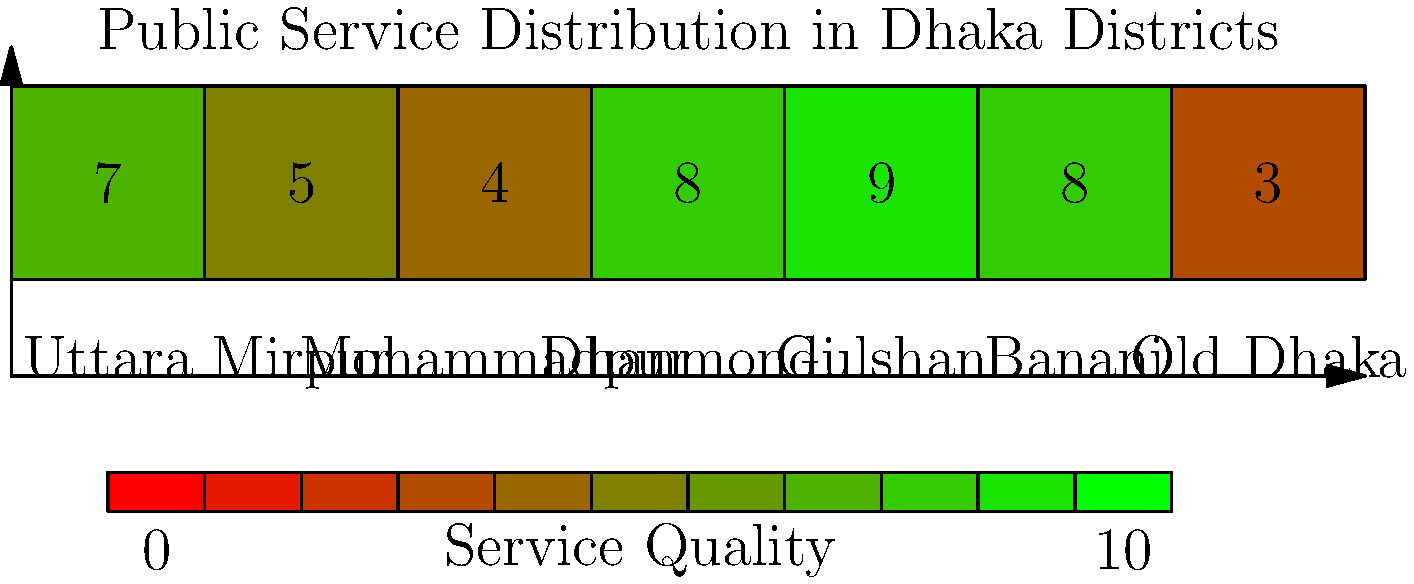Based on the heat map showing the distribution of public services across Dhaka districts, which district appears to have the lowest quality of public services, and what factors might contribute to this discrepancy in service quality? To answer this question, let's analyze the heat map step-by-step:

1. The heat map shows seven districts of Dhaka: Uttara, Mirpur, Mohammadpur, Dhanmondi, Gulshan, Banani, and Old Dhaka.

2. Each district is assigned a score from 0 to 10, with higher scores (greener colors) indicating better public service quality.

3. Examining the scores:
   - Uttara: 7.0
   - Mirpur: 5.0
   - Mohammadpur: 4.0
   - Dhanmondi: 8.0
   - Gulshan: 9.0
   - Banani: 8.0
   - Old Dhaka: 3.0

4. The lowest score is 3.0, corresponding to Old Dhaka.

Factors that might contribute to this discrepancy in service quality:

a) Historical development: Old Dhaka, being the oldest part of the city, may have outdated infrastructure that is more difficult to upgrade.

b) Population density: Old Dhaka is often more densely populated, which can strain existing public services.

c) Socioeconomic factors: The area might have a lower-income population, potentially resulting in less political influence and fewer resources allocated.

d) Urban planning challenges: The narrow streets and older buildings in Old Dhaka can make it more difficult to implement modern public service systems.

e) Resource allocation: Local government corruption or inefficiency might lead to unequal distribution of resources among districts.

f) Accessibility: The congested nature of Old Dhaka might make it harder for service providers to reach and maintain facilities in the area.
Answer: Old Dhaka; historical development, population density, socioeconomic factors, urban planning challenges, resource allocation, and accessibility issues. 